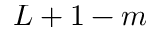<formula> <loc_0><loc_0><loc_500><loc_500>L + 1 - m</formula> 